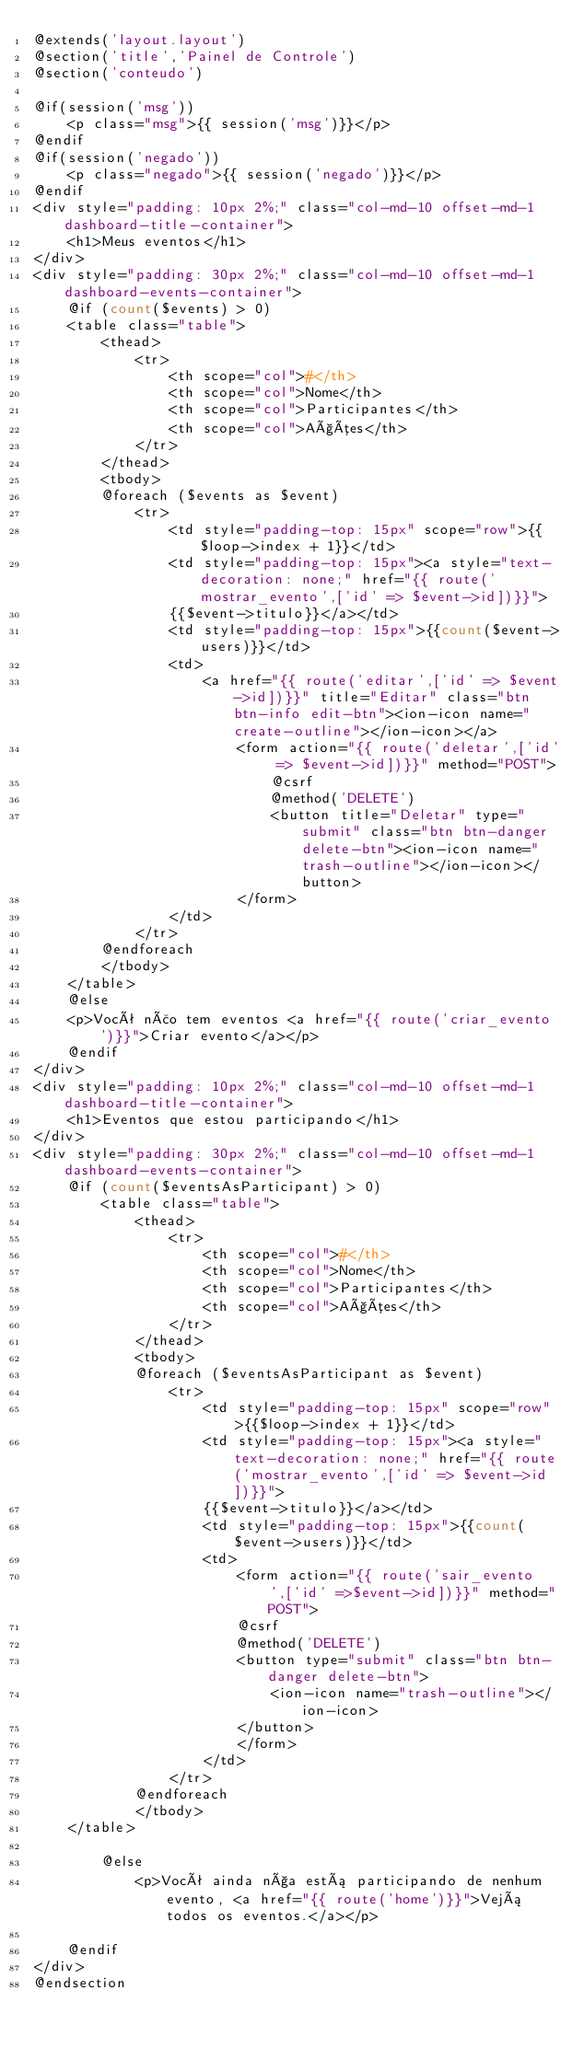<code> <loc_0><loc_0><loc_500><loc_500><_PHP_>@extends('layout.layout')
@section('title','Painel de Controle')
@section('conteudo')

@if(session('msg'))
    <p class="msg">{{ session('msg')}}</p>
@endif
@if(session('negado'))
    <p class="negado">{{ session('negado')}}</p>
@endif
<div style="padding: 10px 2%;" class="col-md-10 offset-md-1 dashboard-title-container">
    <h1>Meus eventos</h1>
</div>
<div style="padding: 30px 2%;" class="col-md-10 offset-md-1 dashboard-events-container">
    @if (count($events) > 0)
    <table class="table">
        <thead>
            <tr>
                <th scope="col">#</th>
                <th scope="col">Nome</th>
                <th scope="col">Participantes</th>
                <th scope="col">Ações</th>
            </tr>
        </thead>
        <tbody>
        @foreach ($events as $event)
            <tr>
                <td style="padding-top: 15px" scope="row">{{$loop->index + 1}}</td>
                <td style="padding-top: 15px"><a style="text-decoration: none;" href="{{ route('mostrar_evento',['id' => $event->id])}}">
                {{$event->titulo}}</a></td>
                <td style="padding-top: 15px">{{count($event->users)}}</td>
                <td>
                    <a href="{{ route('editar',['id' => $event->id])}}" title="Editar" class="btn btn-info edit-btn"><ion-icon name="create-outline"></ion-icon></a>
                        <form action="{{ route('deletar',['id' => $event->id])}}" method="POST">
                            @csrf
                            @method('DELETE')
                            <button title="Deletar" type="submit" class="btn btn-danger delete-btn"><ion-icon name="trash-outline"></ion-icon></button>
                        </form>
                </td>
            </tr>
        @endforeach
        </tbody>
    </table>
    @else
    <p>Você não tem eventos <a href="{{ route('criar_evento')}}">Criar evento</a></p>
    @endif
</div>
<div style="padding: 10px 2%;" class="col-md-10 offset-md-1 dashboard-title-container">
    <h1>Eventos que estou participando</h1>
</div>
<div style="padding: 30px 2%;" class="col-md-10 offset-md-1 dashboard-events-container">
    @if (count($eventsAsParticipant) > 0)
        <table class="table">
            <thead>
                <tr>
                    <th scope="col">#</th>
                    <th scope="col">Nome</th>
                    <th scope="col">Participantes</th>
                    <th scope="col">Ações</th>
                </tr>
            </thead>
            <tbody>
            @foreach ($eventsAsParticipant as $event)
                <tr>
                    <td style="padding-top: 15px" scope="row">{{$loop->index + 1}}</td>
                    <td style="padding-top: 15px"><a style="text-decoration: none;" href="{{ route('mostrar_evento',['id' => $event->id])}}">
                    {{$event->titulo}}</a></td>
                    <td style="padding-top: 15px">{{count($event->users)}}</td>
                    <td>
                        <form action="{{ route('sair_evento',['id' =>$event->id])}}" method="POST">
                        @csrf
                        @method('DELETE')
                        <button type="submit" class="btn btn-danger delete-btn">
                            <ion-icon name="trash-outline"></ion-icon>
                        </button>
                        </form>
                    </td>
                </tr>
            @endforeach
            </tbody>
    </table>

        @else
            <p>Você ainda nça está participando de nenhum evento, <a href="{{ route('home')}}">Vejá todos os eventos.</a></p>

    @endif
</div>
@endsection
</code> 